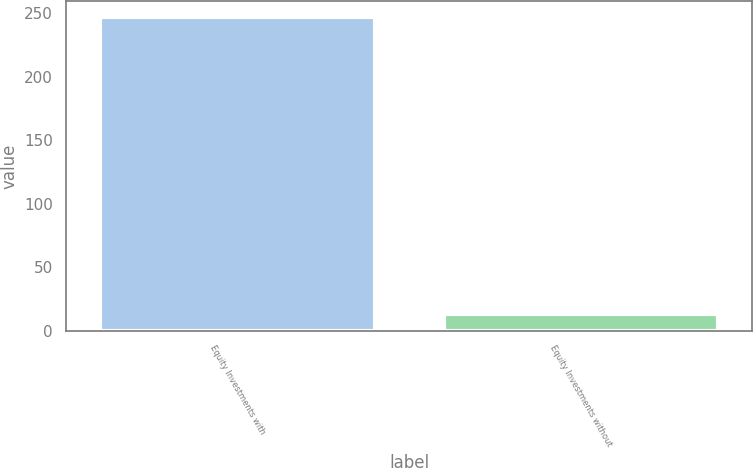<chart> <loc_0><loc_0><loc_500><loc_500><bar_chart><fcel>Equity Investments with<fcel>Equity Investments without<nl><fcel>247<fcel>13<nl></chart> 